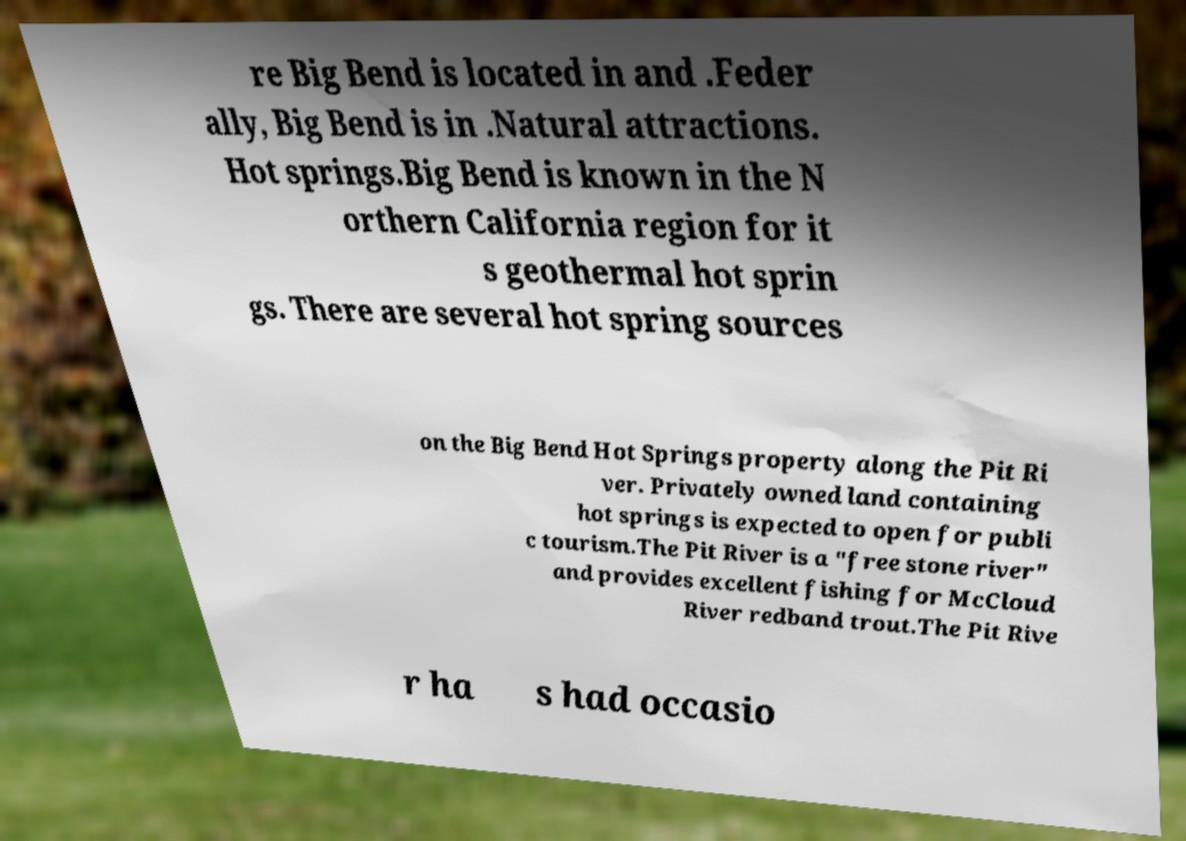I need the written content from this picture converted into text. Can you do that? re Big Bend is located in and .Feder ally, Big Bend is in .Natural attractions. Hot springs.Big Bend is known in the N orthern California region for it s geothermal hot sprin gs. There are several hot spring sources on the Big Bend Hot Springs property along the Pit Ri ver. Privately owned land containing hot springs is expected to open for publi c tourism.The Pit River is a "free stone river" and provides excellent fishing for McCloud River redband trout.The Pit Rive r ha s had occasio 